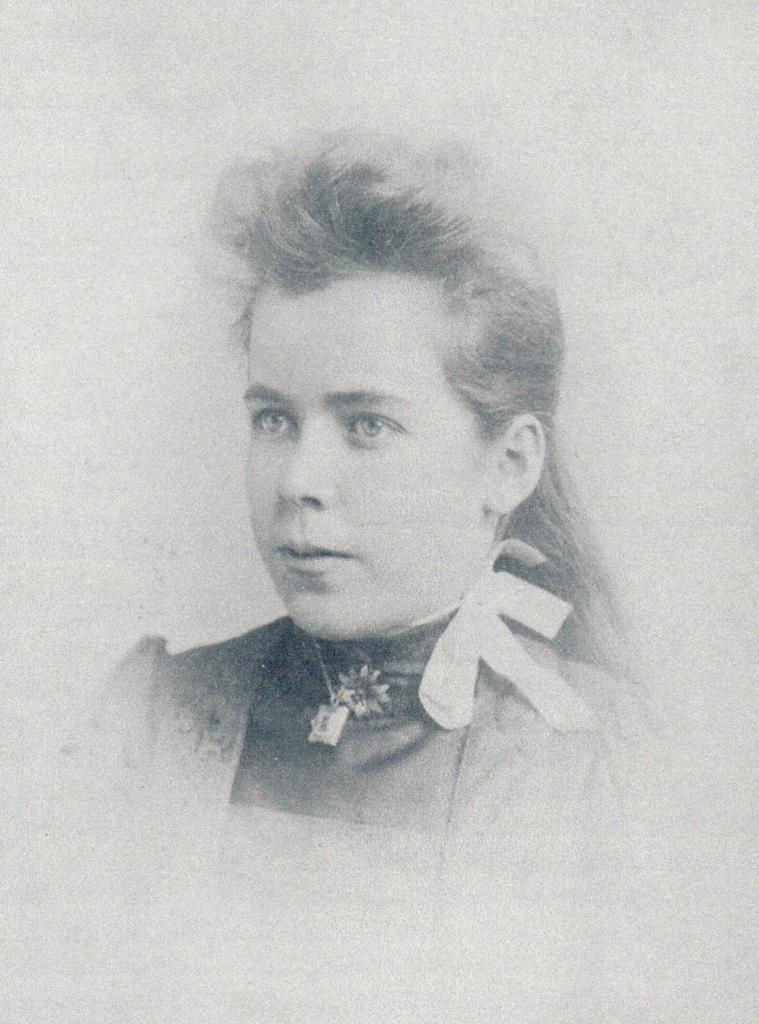What is the main subject of the image? The main subject of the image is a portrait of a woman. What color scheme is used in the portrait? The portrait is in black and white. What color is the background of the image? The background of the image is white in color. What type of soap is being used in the meeting depicted in the image? There is no meeting or soap present in the image; it contains a black and white portrait of a woman with a white background. 